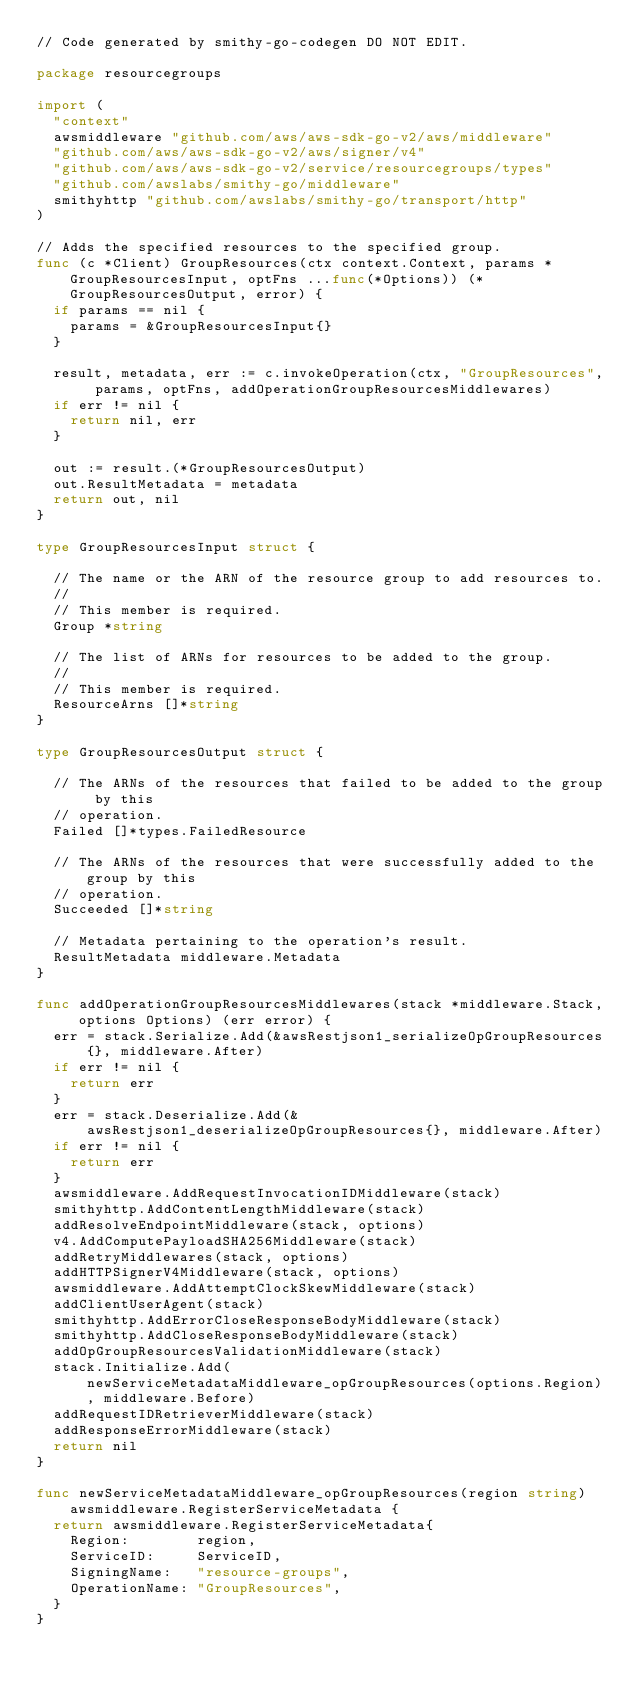<code> <loc_0><loc_0><loc_500><loc_500><_Go_>// Code generated by smithy-go-codegen DO NOT EDIT.

package resourcegroups

import (
	"context"
	awsmiddleware "github.com/aws/aws-sdk-go-v2/aws/middleware"
	"github.com/aws/aws-sdk-go-v2/aws/signer/v4"
	"github.com/aws/aws-sdk-go-v2/service/resourcegroups/types"
	"github.com/awslabs/smithy-go/middleware"
	smithyhttp "github.com/awslabs/smithy-go/transport/http"
)

// Adds the specified resources to the specified group.
func (c *Client) GroupResources(ctx context.Context, params *GroupResourcesInput, optFns ...func(*Options)) (*GroupResourcesOutput, error) {
	if params == nil {
		params = &GroupResourcesInput{}
	}

	result, metadata, err := c.invokeOperation(ctx, "GroupResources", params, optFns, addOperationGroupResourcesMiddlewares)
	if err != nil {
		return nil, err
	}

	out := result.(*GroupResourcesOutput)
	out.ResultMetadata = metadata
	return out, nil
}

type GroupResourcesInput struct {

	// The name or the ARN of the resource group to add resources to.
	//
	// This member is required.
	Group *string

	// The list of ARNs for resources to be added to the group.
	//
	// This member is required.
	ResourceArns []*string
}

type GroupResourcesOutput struct {

	// The ARNs of the resources that failed to be added to the group by this
	// operation.
	Failed []*types.FailedResource

	// The ARNs of the resources that were successfully added to the group by this
	// operation.
	Succeeded []*string

	// Metadata pertaining to the operation's result.
	ResultMetadata middleware.Metadata
}

func addOperationGroupResourcesMiddlewares(stack *middleware.Stack, options Options) (err error) {
	err = stack.Serialize.Add(&awsRestjson1_serializeOpGroupResources{}, middleware.After)
	if err != nil {
		return err
	}
	err = stack.Deserialize.Add(&awsRestjson1_deserializeOpGroupResources{}, middleware.After)
	if err != nil {
		return err
	}
	awsmiddleware.AddRequestInvocationIDMiddleware(stack)
	smithyhttp.AddContentLengthMiddleware(stack)
	addResolveEndpointMiddleware(stack, options)
	v4.AddComputePayloadSHA256Middleware(stack)
	addRetryMiddlewares(stack, options)
	addHTTPSignerV4Middleware(stack, options)
	awsmiddleware.AddAttemptClockSkewMiddleware(stack)
	addClientUserAgent(stack)
	smithyhttp.AddErrorCloseResponseBodyMiddleware(stack)
	smithyhttp.AddCloseResponseBodyMiddleware(stack)
	addOpGroupResourcesValidationMiddleware(stack)
	stack.Initialize.Add(newServiceMetadataMiddleware_opGroupResources(options.Region), middleware.Before)
	addRequestIDRetrieverMiddleware(stack)
	addResponseErrorMiddleware(stack)
	return nil
}

func newServiceMetadataMiddleware_opGroupResources(region string) awsmiddleware.RegisterServiceMetadata {
	return awsmiddleware.RegisterServiceMetadata{
		Region:        region,
		ServiceID:     ServiceID,
		SigningName:   "resource-groups",
		OperationName: "GroupResources",
	}
}
</code> 